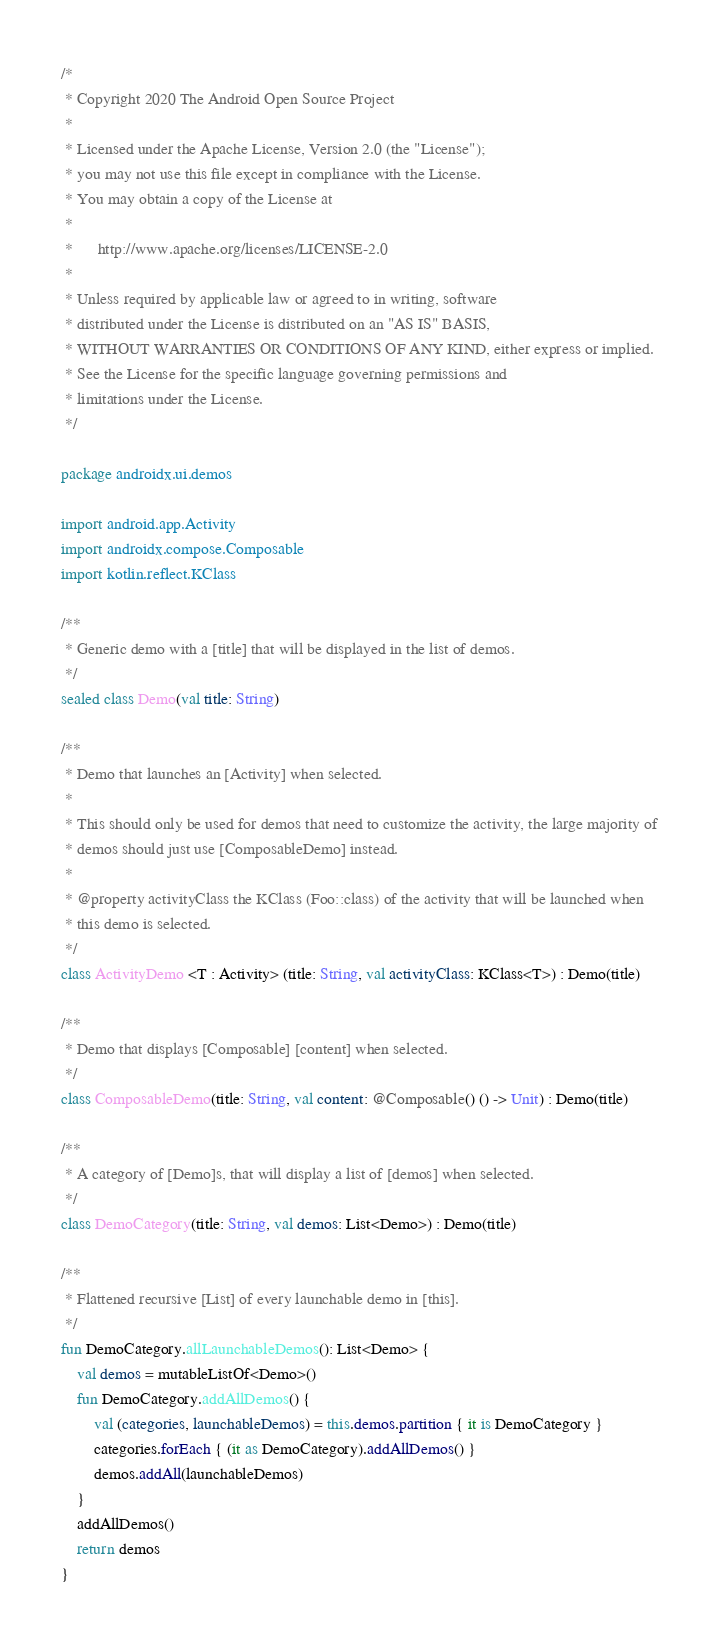Convert code to text. <code><loc_0><loc_0><loc_500><loc_500><_Kotlin_>/*
 * Copyright 2020 The Android Open Source Project
 *
 * Licensed under the Apache License, Version 2.0 (the "License");
 * you may not use this file except in compliance with the License.
 * You may obtain a copy of the License at
 *
 *      http://www.apache.org/licenses/LICENSE-2.0
 *
 * Unless required by applicable law or agreed to in writing, software
 * distributed under the License is distributed on an "AS IS" BASIS,
 * WITHOUT WARRANTIES OR CONDITIONS OF ANY KIND, either express or implied.
 * See the License for the specific language governing permissions and
 * limitations under the License.
 */

package androidx.ui.demos

import android.app.Activity
import androidx.compose.Composable
import kotlin.reflect.KClass

/**
 * Generic demo with a [title] that will be displayed in the list of demos.
 */
sealed class Demo(val title: String)

/**
 * Demo that launches an [Activity] when selected.
 *
 * This should only be used for demos that need to customize the activity, the large majority of
 * demos should just use [ComposableDemo] instead.
 *
 * @property activityClass the KClass (Foo::class) of the activity that will be launched when
 * this demo is selected.
 */
class ActivityDemo <T : Activity> (title: String, val activityClass: KClass<T>) : Demo(title)

/**
 * Demo that displays [Composable] [content] when selected.
 */
class ComposableDemo(title: String, val content: @Composable() () -> Unit) : Demo(title)

/**
 * A category of [Demo]s, that will display a list of [demos] when selected.
 */
class DemoCategory(title: String, val demos: List<Demo>) : Demo(title)

/**
 * Flattened recursive [List] of every launchable demo in [this].
 */
fun DemoCategory.allLaunchableDemos(): List<Demo> {
    val demos = mutableListOf<Demo>()
    fun DemoCategory.addAllDemos() {
        val (categories, launchableDemos) = this.demos.partition { it is DemoCategory }
        categories.forEach { (it as DemoCategory).addAllDemos() }
        demos.addAll(launchableDemos)
    }
    addAllDemos()
    return demos
}
</code> 